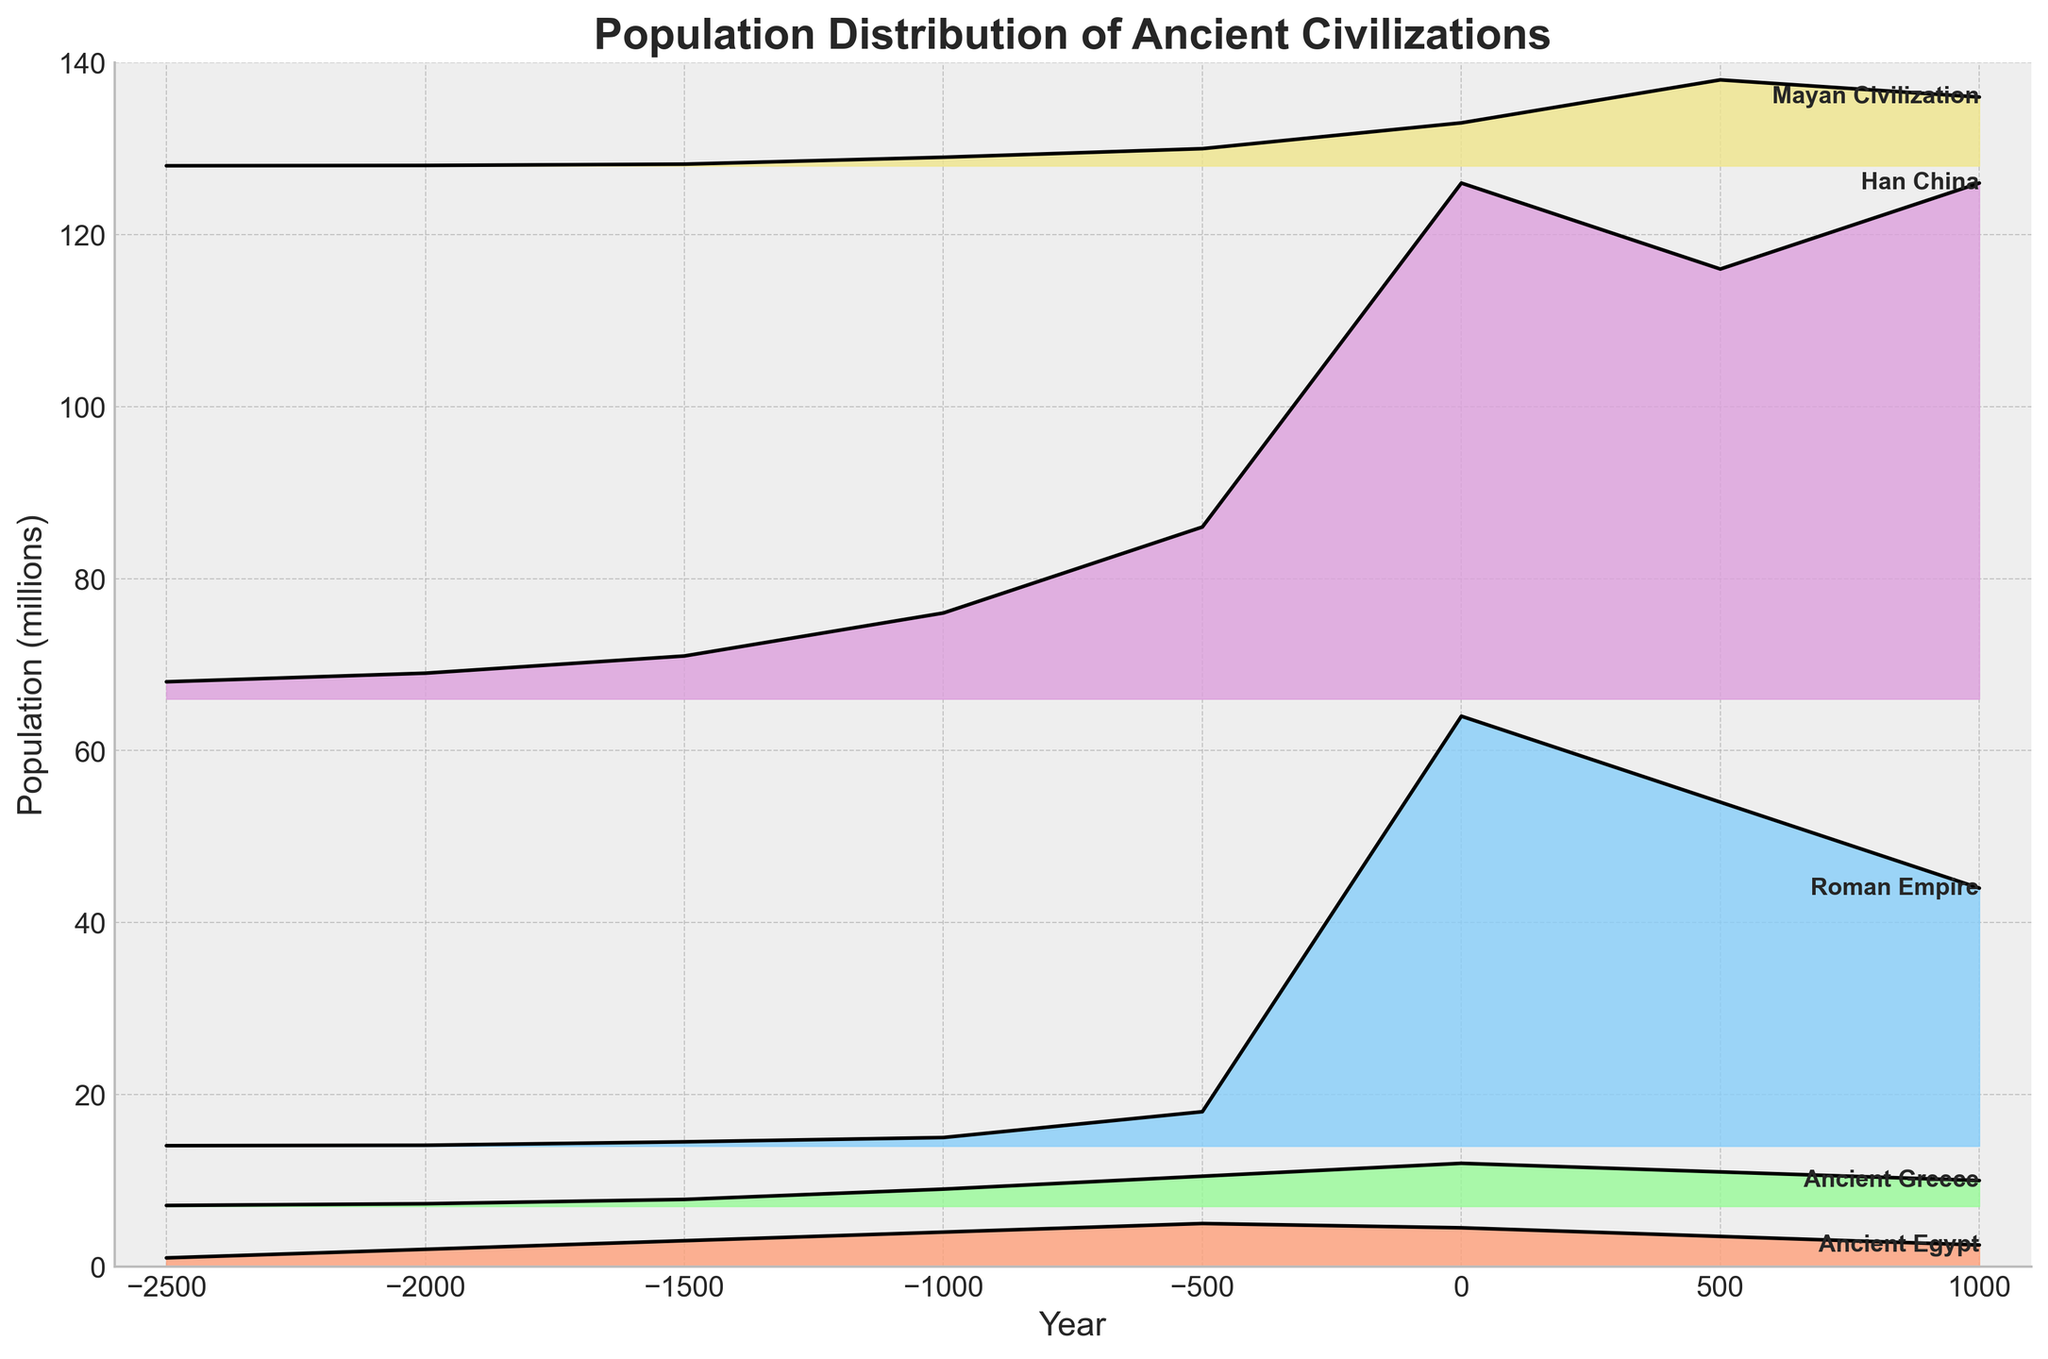What is the population trend of Ancient Egypt based on the plot? The plot shows that the population of Ancient Egypt started at 1 million around 2500 BCE, increased to 5 million by 500 BCE, then decreased to 4.5 million around the start of the Common Era and continued to decline further to 2.5 million by 1000 CE.
Answer: Declining after a peak Which civilization had the highest population around the year 0? The plot shows the population peaks at 50 million for the Roman Empire and 60 million for Han China around the year 0, thus Han China had the highest population at that time.
Answer: Han China During which period did the Mayan Civilization experience its greatest population growth? The plot indicates that the Mayans experienced their greatest population growth between -1000 BCE and 500 BCE, where the population rose from approximately 200,000 to 2 million.
Answer: -1000 BCE to 500 BCE How did the population of the Roman Empire change between 500 BCE and 500 CE? The plot shows that the population of the Roman Empire increased from approximately 4 million in 500 BCE to around 50 million by the start of the Common Era, and then slightly decreased to 40 million by 500 CE.
Answer: Increase then decrease Which civilizations had a population greater than 5 million around 500 CE? The plot indicates that by 500 CE, only Han China and the Mayan Civilization had populations exceeding 5 million, with Han China having around 50 million and the Mayan civilization having around 10 million.
Answer: Han China and Mayan Civilization What is the difference in population between Ancient Greece and the Han China at their peak? The peak population of Ancient Greece was approximately 5 million, and Han China's was around 60 million. The difference between their peak populations is 60 million - 5 million = 55 million.
Answer: 55 million Which civilization showed a sharp population decrease after reaching its peak? The plot shows that the Roman Empire had a sharp decline after its peak population around the year 0 CE, decreasing from around 50 million to 30 million by 1000 CE.
Answer: Roman Empire Compare the population trajectories of Ancient Egypt and Ancient Greece. Figuring from the plot, Ancient Egypt’s population increased steadily until around 500 BCE and then began to decline. Ancient Greece saw a more rapid rise in population, peaking around the start of the Common Era and declining after that.
Answer: Steady increase then decline vs rapid rise then decline What was the population difference between Han China and the Mayan Civilization in 1000 CE? According to the plot, Han China's population was around 60 million and the Mayan Civilization's population was around 8 million at 1000 CE. Thus, the difference is 60 million - 8 million = 52 million.
Answer: 52 million What is the range of population values depicted for Han China over the entire timeline? The plot shows Han China's population ranging from 2 million around 2500 BCE to 60 million by around 0 CE, so the range is 60 million - 2 million = 58 million.
Answer: 58 million 